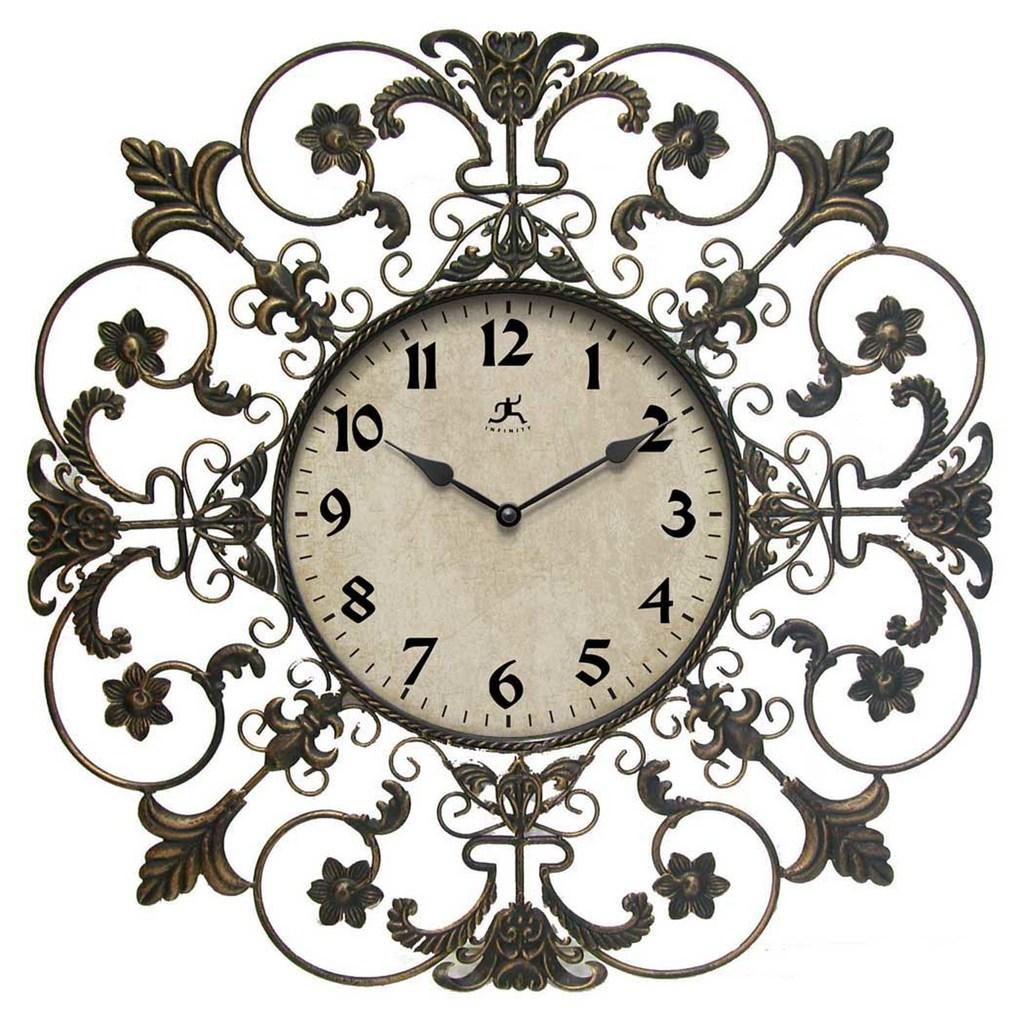Provide a one-sentence caption for the provided image. Clock showing the hands on the number 10 and 2. 